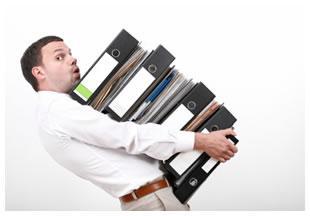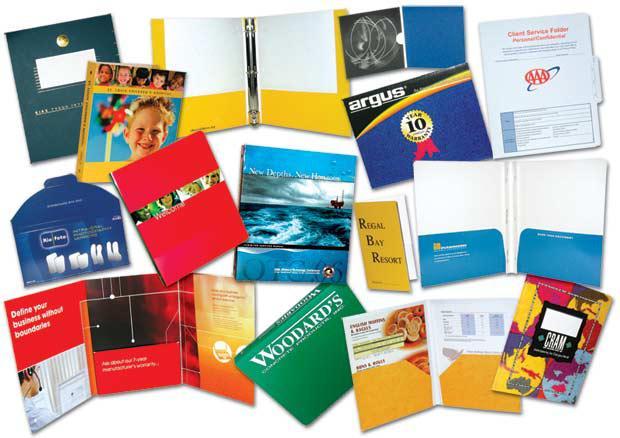The first image is the image on the left, the second image is the image on the right. Evaluate the accuracy of this statement regarding the images: "A person is grasping a vertical stack of binders in one image.". Is it true? Answer yes or no. Yes. The first image is the image on the left, the second image is the image on the right. For the images shown, is this caption "there are at least five colored binders in the image on the left" true? Answer yes or no. No. 